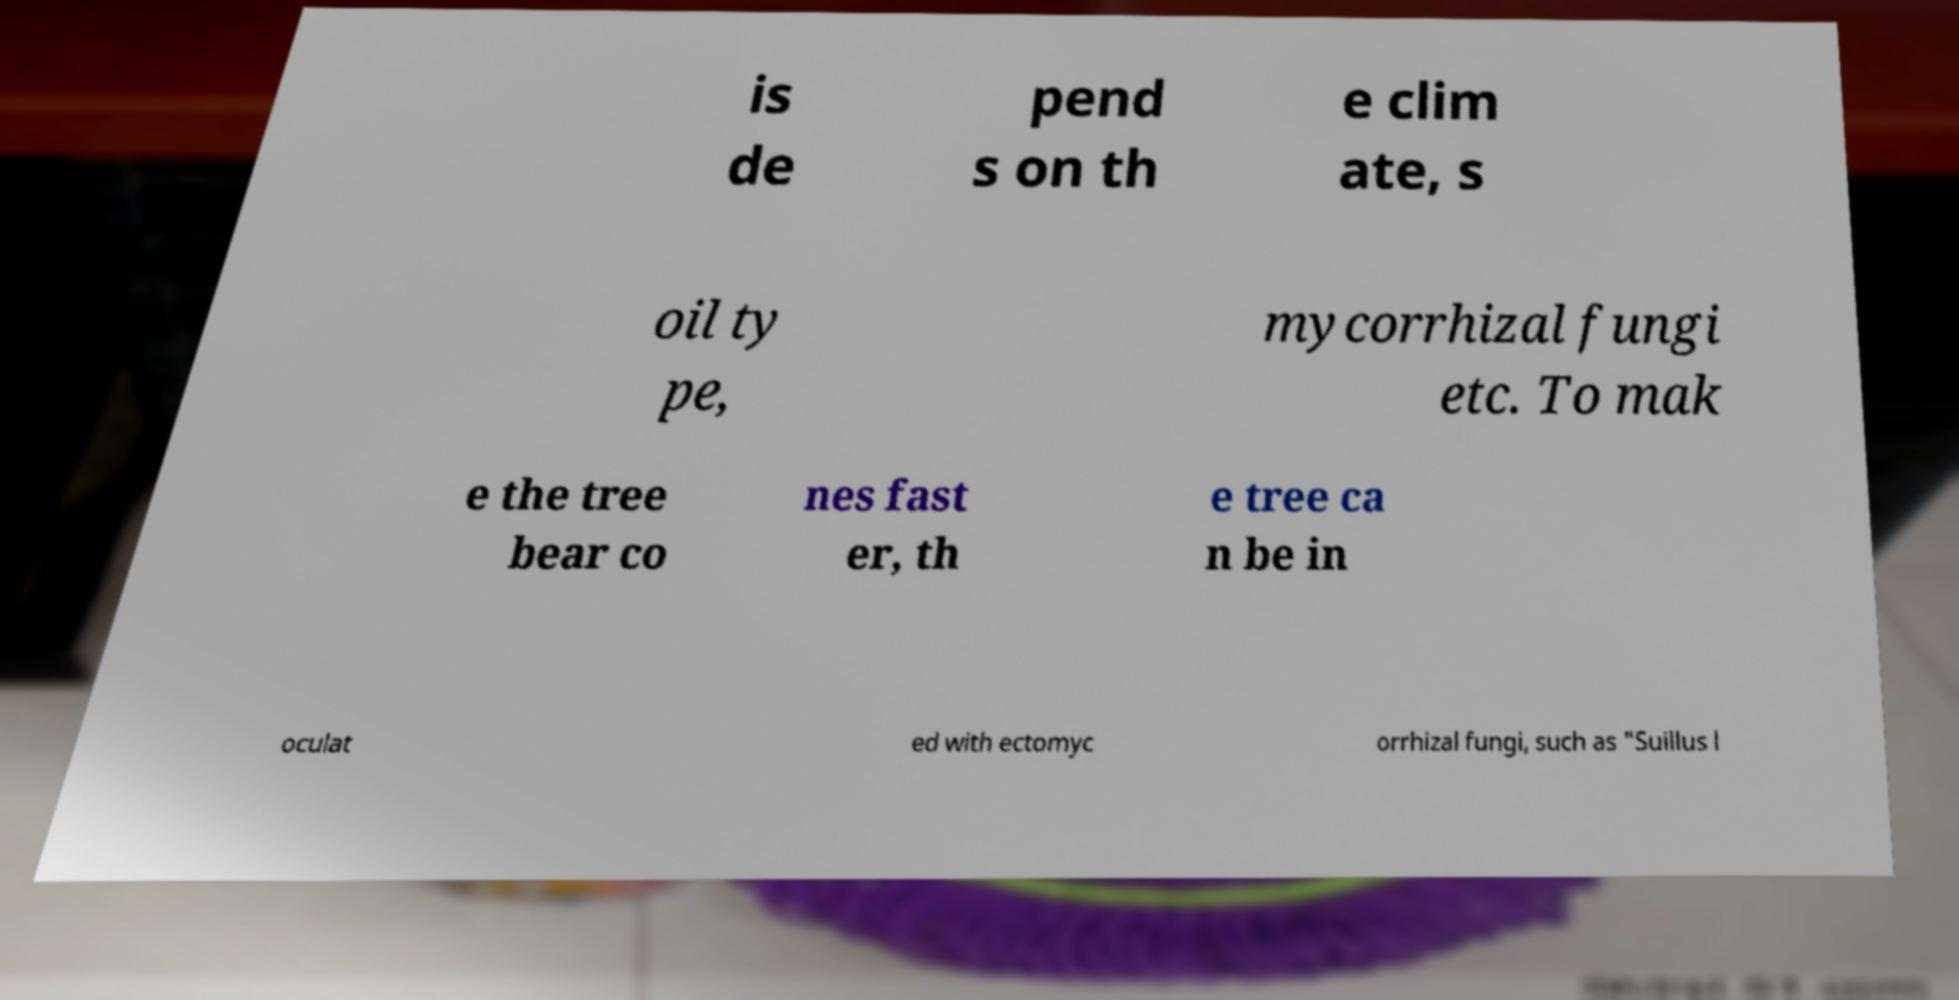Can you read and provide the text displayed in the image?This photo seems to have some interesting text. Can you extract and type it out for me? is de pend s on th e clim ate, s oil ty pe, mycorrhizal fungi etc. To mak e the tree bear co nes fast er, th e tree ca n be in oculat ed with ectomyc orrhizal fungi, such as "Suillus l 